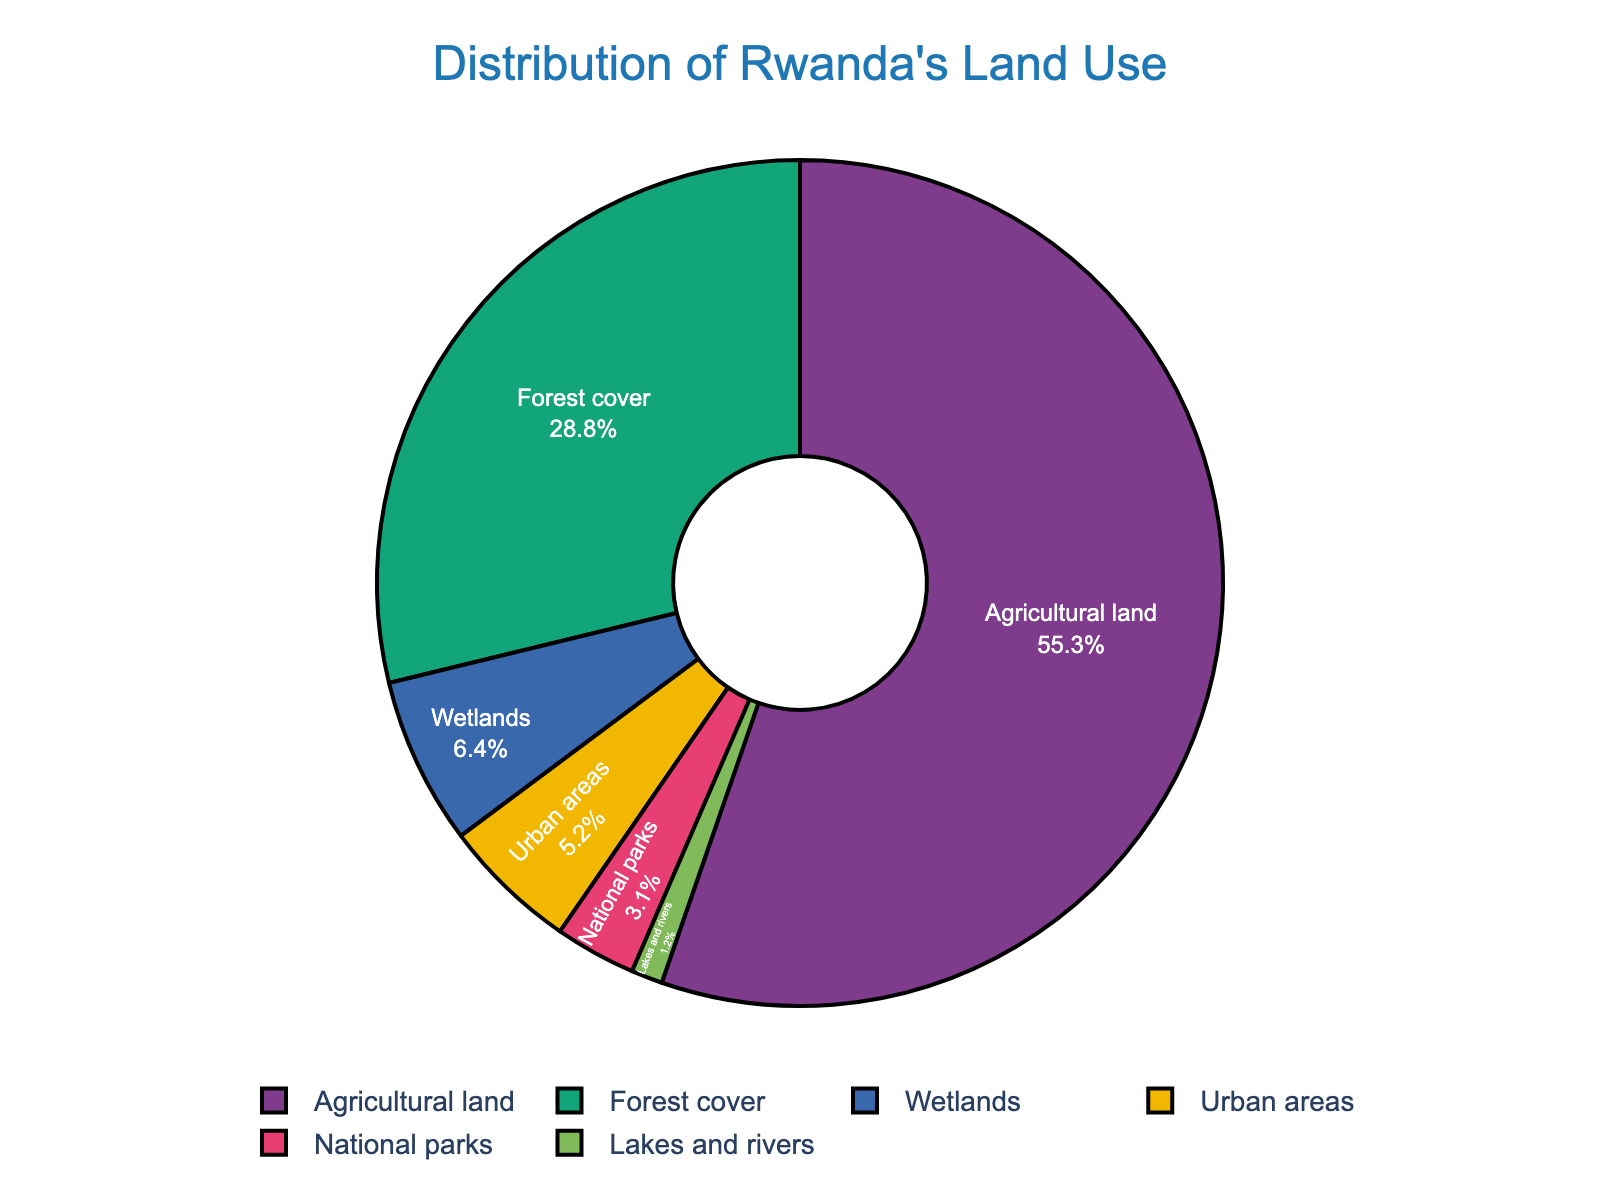What percentage of Rwanda's land is used for agricultural purposes? Look at the pie chart segment labeled "Agricultural land" and note the percentage value associated with it.
Answer: 55.3% Which category covers the least amount of land in Rwanda? Identify the smallest segment in the pie chart and read off the category label attached to it.
Answer: Lakes and rivers How much more land is used for agriculture than for forest cover? Subtract the forest cover percentage from the agricultural land percentage: 55.3% - 28.8% = 26.5%.
Answer: 26.5% What is the combined percentage of urban areas and wetlands? Sum the percentages of urban areas (5.2%) and wetlands (6.4%): 5.2% + 6.4% = 11.6%.
Answer: 11.6% Is the area covered by national parks greater than or less than the area covered by lakes and rivers? Compare the percentages for national parks (3.1%) and lakes and rivers (1.2%).
Answer: Greater What proportion of Rwanda’s land is covered by water (lakes and rivers)? Look at the pie chart segment labeled "Lakes and rivers" and note the percentage value.
Answer: 1.2% How does the forest cover compare to the combined area of wetlands and national parks? Compare the percentage of forest cover (28.8%) with the sum of wetlands (6.4%) and national parks (3.1%): 6.4% + 3.1% = 9.5%. Forest cover (28.8%) is greater than 9.5%.
Answer: Greater Which category has a larger share, urban areas or national parks? Compare the percentages for urban areas (5.2%) and national parks (3.1%).
Answer: Urban areas What percentage of land is not used for agriculture? Subtract the percentage of agricultural land (55.3%) from 100%: 100% - 55.3% = 44.7%.
Answer: 44.7% 